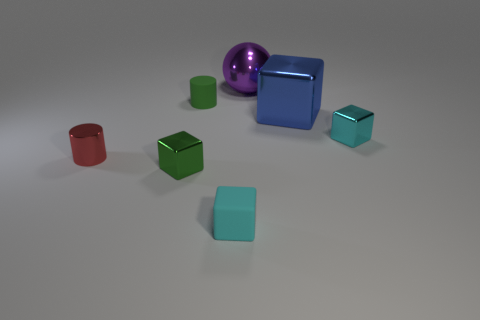What time of day or lighting condition is suggested by the shadows in the image? The shadows in the image suggest an artificial lighting condition—likely from above and somewhat to the left, based on the direction and length of the shadows cast by the objects on the surface. Can you tell if the light source is direct or diffused, and what does that tell us about the setting? The light source appears to be direct, as indicated by the sharp and clear-cut edges of the shadows. This typically suggests that the objects are indoors under a controlled lighting environment, such as a studio or a room with a single spotlight. 